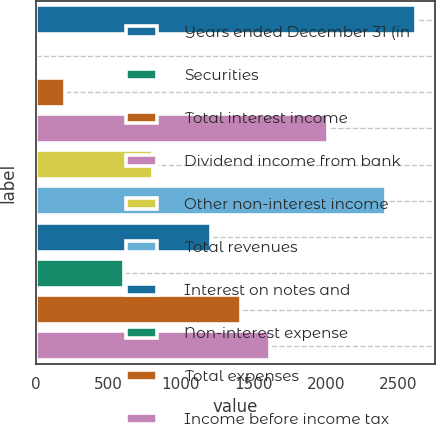<chart> <loc_0><loc_0><loc_500><loc_500><bar_chart><fcel>Years ended December 31 (in<fcel>Securities<fcel>Total interest income<fcel>Dividend income from bank<fcel>Other non-interest income<fcel>Total revenues<fcel>Interest on notes and<fcel>Non-interest expense<fcel>Total expenses<fcel>Income before income tax<nl><fcel>2619.78<fcel>3.4<fcel>204.66<fcel>2016<fcel>808.44<fcel>2418.52<fcel>1210.96<fcel>607.18<fcel>1412.22<fcel>1613.48<nl></chart> 